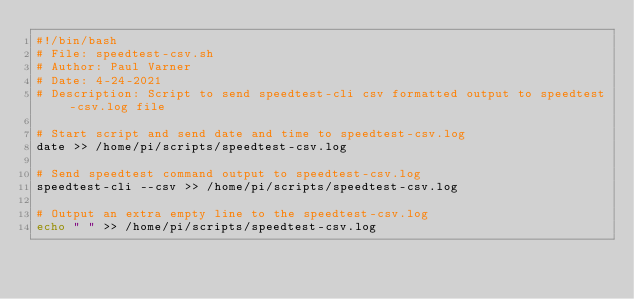<code> <loc_0><loc_0><loc_500><loc_500><_Bash_>#!/bin/bash
# File: speedtest-csv.sh
# Author: Paul Varner 
# Date: 4-24-2021
# Description: Script to send speedtest-cli csv formatted output to speedtest-csv.log file

# Start script and send date and time to speedtest-csv.log
date >> /home/pi/scripts/speedtest-csv.log

# Send speedtest command output to speedtest-csv.log
speedtest-cli --csv >> /home/pi/scripts/speedtest-csv.log

# Output an extra empty line to the speedtest-csv.log
echo " " >> /home/pi/scripts/speedtest-csv.log
</code> 